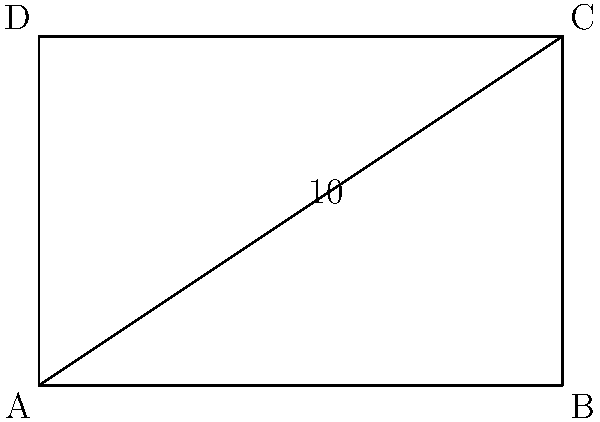The Phoenix Central Station is rectangular in shape. If the diagonal of the station measures 10 units and the width is 6 units, what is the perimeter of the station? Let's approach this step-by-step:

1) We know that the station is rectangular, so we can use the Pythagorean theorem.

2) Let's denote the width as $w$ and the length as $l$. We're given that $w = 6$ units.

3) The diagonal forms the hypotenuse of a right triangle. Using the Pythagorean theorem:

   $w^2 + l^2 = diagonal^2$

4) Substituting the known values:

   $6^2 + l^2 = 10^2$

5) Simplify:

   $36 + l^2 = 100$

6) Solve for $l$:

   $l^2 = 64$
   $l = 8$ units

7) Now we know both dimensions of the rectangle: width = 6 units, length = 8 units.

8) The perimeter of a rectangle is given by the formula: $P = 2(l + w)$

9) Substituting our values:

   $P = 2(8 + 6) = 2(14) = 28$ units

Therefore, the perimeter of the Phoenix Central Station is 28 units.
Answer: 28 units 